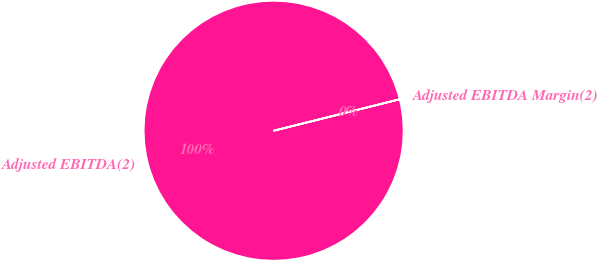Convert chart. <chart><loc_0><loc_0><loc_500><loc_500><pie_chart><fcel>Adjusted EBITDA(2)<fcel>Adjusted EBITDA Margin(2)<nl><fcel>100.0%<fcel>0.0%<nl></chart> 